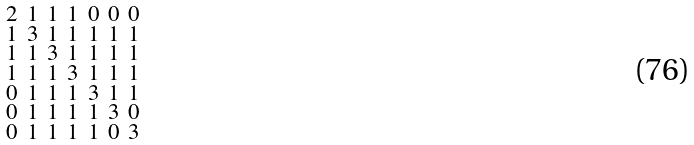<formula> <loc_0><loc_0><loc_500><loc_500>\begin{smallmatrix} 2 & 1 & 1 & 1 & 0 & 0 & 0 \\ 1 & 3 & 1 & 1 & 1 & 1 & 1 \\ 1 & 1 & 3 & 1 & 1 & 1 & 1 \\ 1 & 1 & 1 & 3 & 1 & 1 & 1 \\ 0 & 1 & 1 & 1 & 3 & 1 & 1 \\ 0 & 1 & 1 & 1 & 1 & 3 & 0 \\ 0 & 1 & 1 & 1 & 1 & 0 & 3 \end{smallmatrix}</formula> 